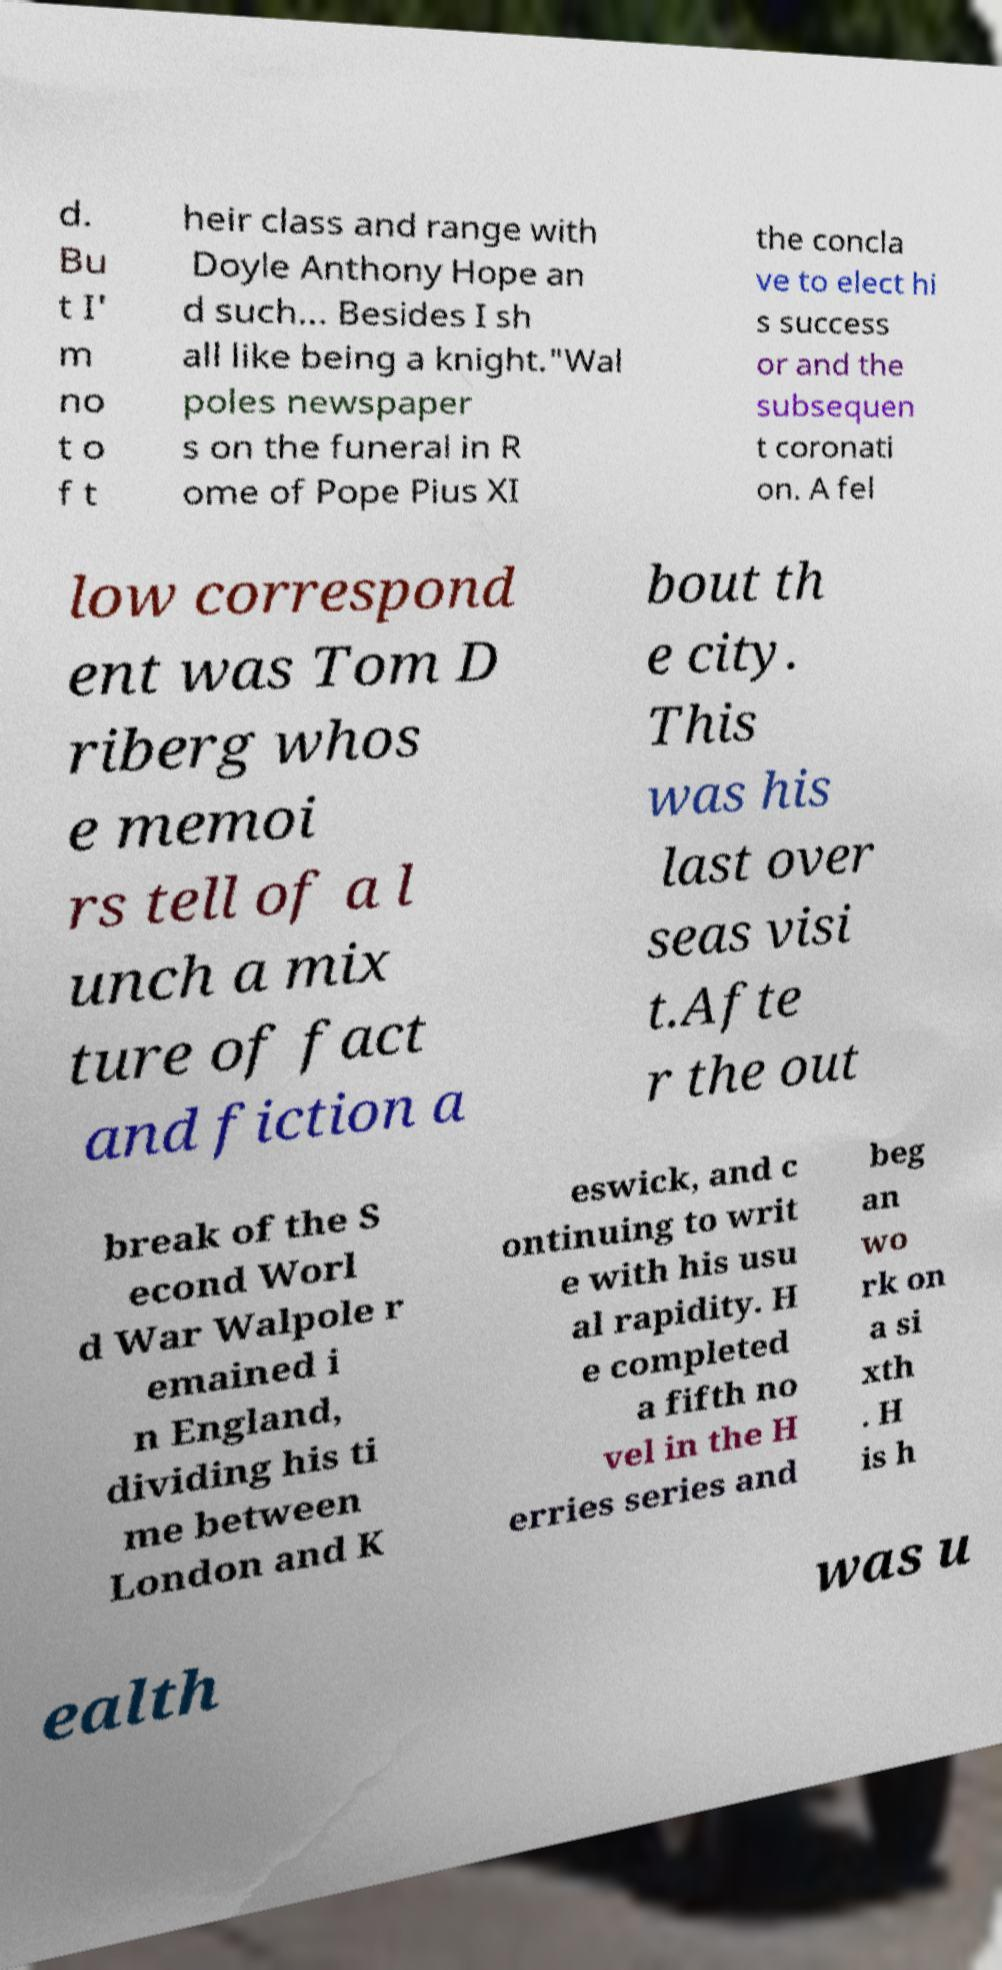Can you accurately transcribe the text from the provided image for me? d. Bu t I' m no t o f t heir class and range with Doyle Anthony Hope an d such... Besides I sh all like being a knight."Wal poles newspaper s on the funeral in R ome of Pope Pius XI the concla ve to elect hi s success or and the subsequen t coronati on. A fel low correspond ent was Tom D riberg whos e memoi rs tell of a l unch a mix ture of fact and fiction a bout th e city. This was his last over seas visi t.Afte r the out break of the S econd Worl d War Walpole r emained i n England, dividing his ti me between London and K eswick, and c ontinuing to writ e with his usu al rapidity. H e completed a fifth no vel in the H erries series and beg an wo rk on a si xth . H is h ealth was u 